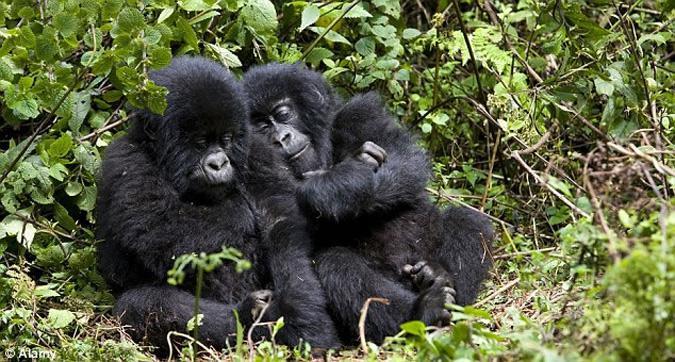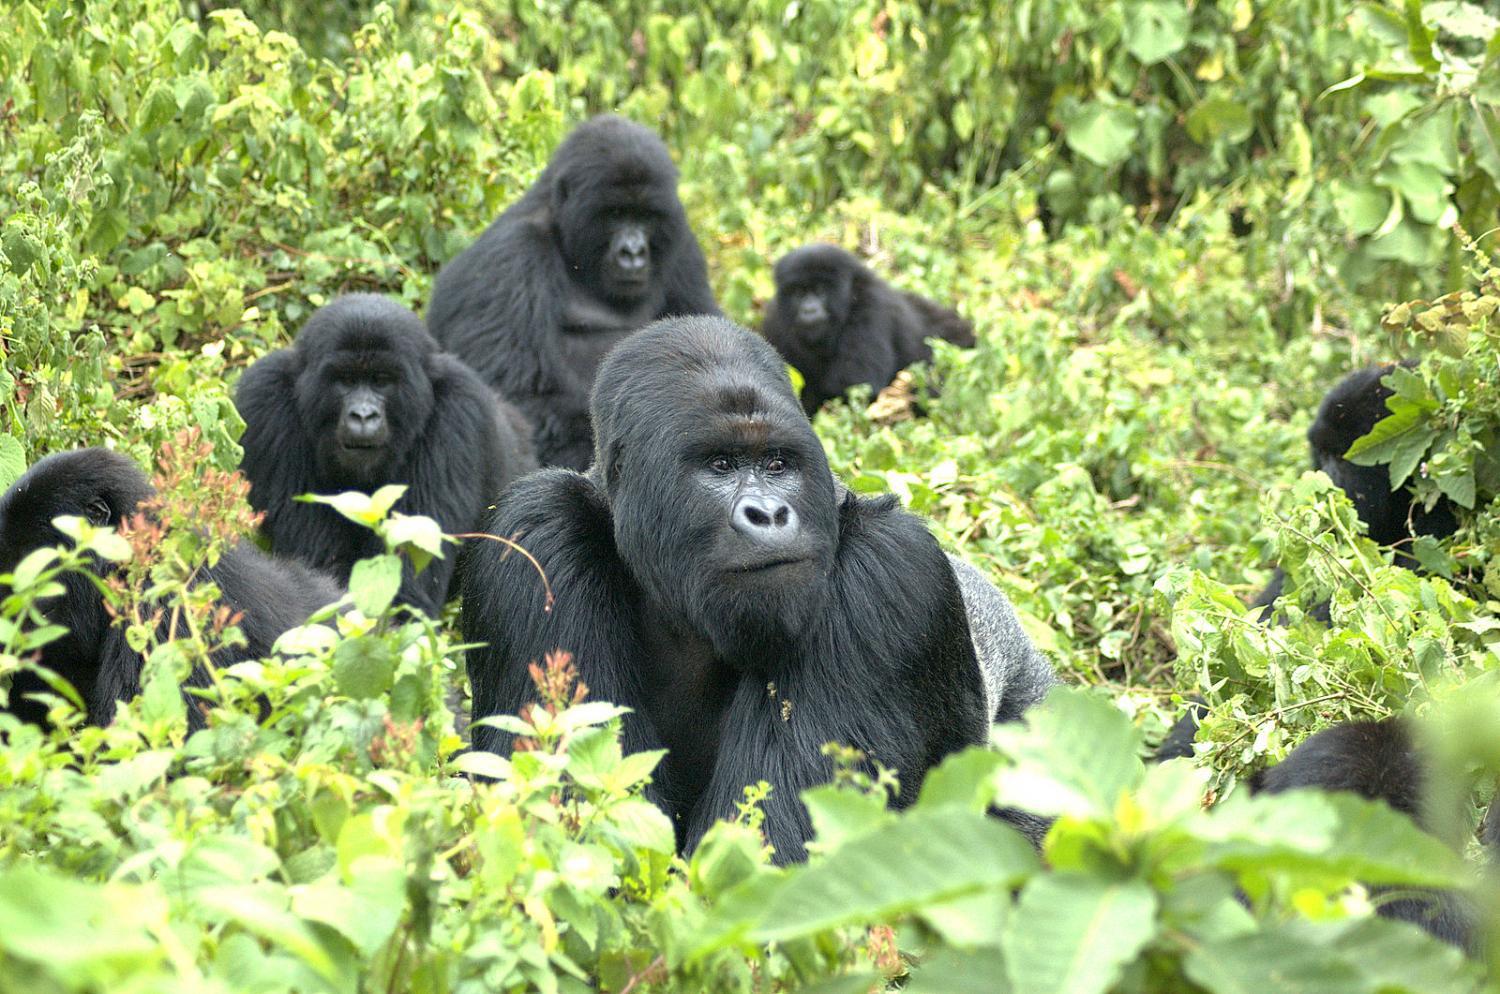The first image is the image on the left, the second image is the image on the right. For the images shown, is this caption "Each image includes a baby gorilla close to an adult gorilla who is facing leftward." true? Answer yes or no. No. 